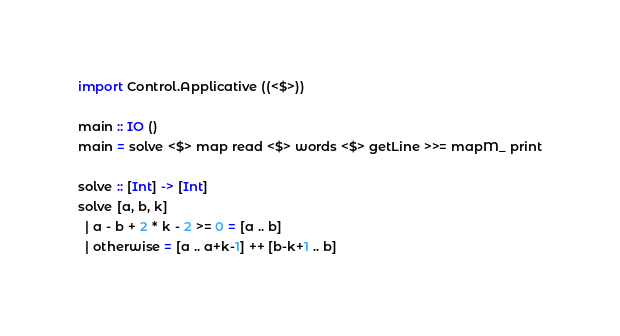Convert code to text. <code><loc_0><loc_0><loc_500><loc_500><_Haskell_>import Control.Applicative ((<$>))

main :: IO ()
main = solve <$> map read <$> words <$> getLine >>= mapM_ print

solve :: [Int] -> [Int]
solve [a, b, k]
  | a - b + 2 * k - 2 >= 0 = [a .. b]
  | otherwise = [a .. a+k-1] ++ [b-k+1 .. b]
</code> 